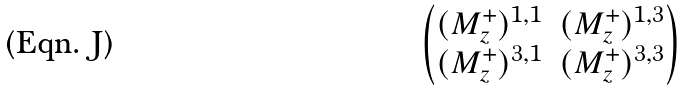Convert formula to latex. <formula><loc_0><loc_0><loc_500><loc_500>\begin{pmatrix} ( M _ { z } ^ { + } ) ^ { 1 , 1 } & ( M _ { z } ^ { + } ) ^ { 1 , 3 } \\ ( M _ { z } ^ { + } ) ^ { 3 , 1 } & ( M _ { z } ^ { + } ) ^ { 3 , 3 } \end{pmatrix}</formula> 